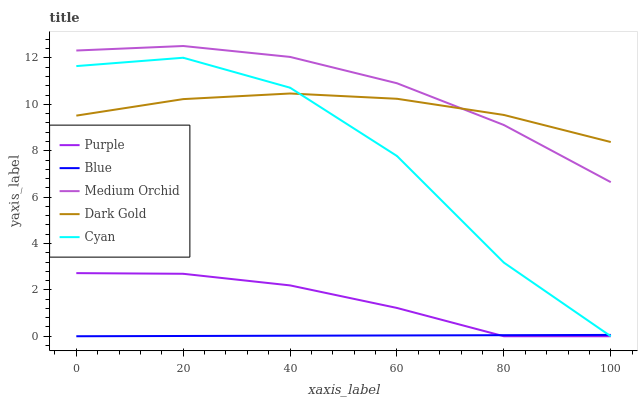Does Blue have the minimum area under the curve?
Answer yes or no. Yes. Does Medium Orchid have the maximum area under the curve?
Answer yes or no. Yes. Does Cyan have the minimum area under the curve?
Answer yes or no. No. Does Cyan have the maximum area under the curve?
Answer yes or no. No. Is Blue the smoothest?
Answer yes or no. Yes. Is Cyan the roughest?
Answer yes or no. Yes. Is Cyan the smoothest?
Answer yes or no. No. Is Blue the roughest?
Answer yes or no. No. Does Medium Orchid have the lowest value?
Answer yes or no. No. Does Cyan have the highest value?
Answer yes or no. No. Is Purple less than Dark Gold?
Answer yes or no. Yes. Is Medium Orchid greater than Cyan?
Answer yes or no. Yes. Does Purple intersect Dark Gold?
Answer yes or no. No. 